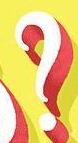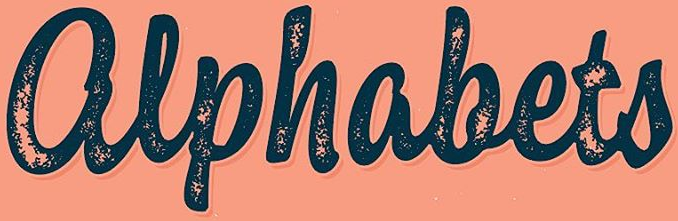Read the text from these images in sequence, separated by a semicolon. ?; alphabets 